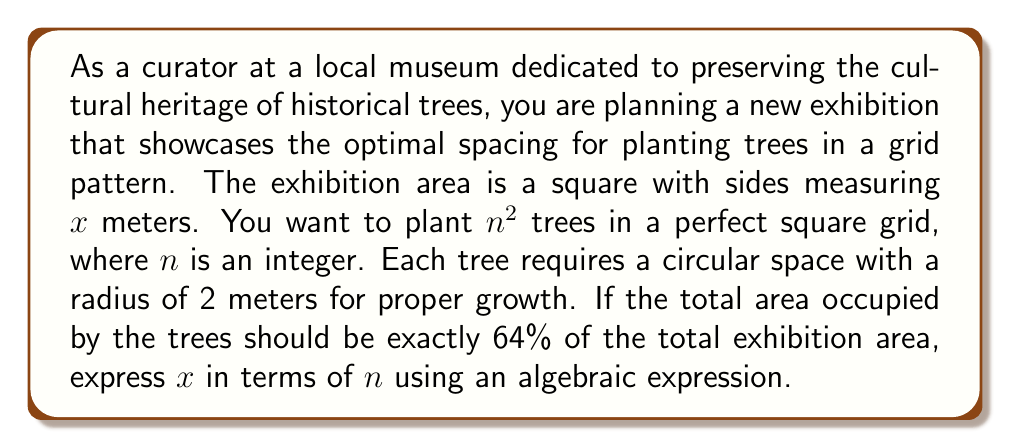Give your solution to this math problem. Let's approach this problem step by step:

1) The total area of the exhibition is $x^2$ square meters.

2) Each tree requires a circular space with a radius of 2 meters. The area of this circle is:
   $A_{tree} = \pi r^2 = \pi (2)^2 = 4\pi$ square meters

3) There are $n^2$ trees in total, so the total area occupied by the trees is:
   $A_{total\_trees} = n^2 \cdot 4\pi$ square meters

4) We're told that the area occupied by the trees should be exactly 64% of the total exhibition area. We can express this as an equation:

   $n^2 \cdot 4\pi = 0.64x^2$

5) Now, let's solve this equation for $x$:

   $x^2 = \frac{n^2 \cdot 4\pi}{0.64}$

6) Simplify the right side:

   $x^2 = \frac{25\pi n^2}{4}$

7) Take the square root of both sides:

   $x = \frac{5\sqrt{\pi}n}{2}$

This gives us $x$ in terms of $n$.
Answer: $x = \frac{5\sqrt{\pi}n}{2}$ 